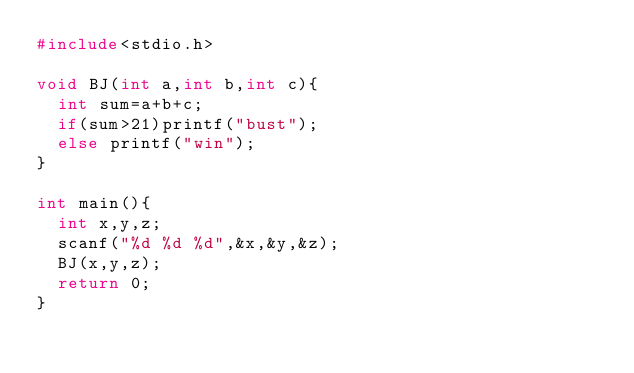<code> <loc_0><loc_0><loc_500><loc_500><_C_>#include<stdio.h>

void BJ(int a,int b,int c){
  int sum=a+b+c;
  if(sum>21)printf("bust");
  else printf("win");
}

int main(){
  int x,y,z;
  scanf("%d %d %d",&x,&y,&z);
  BJ(x,y,z);
  return 0;
}</code> 